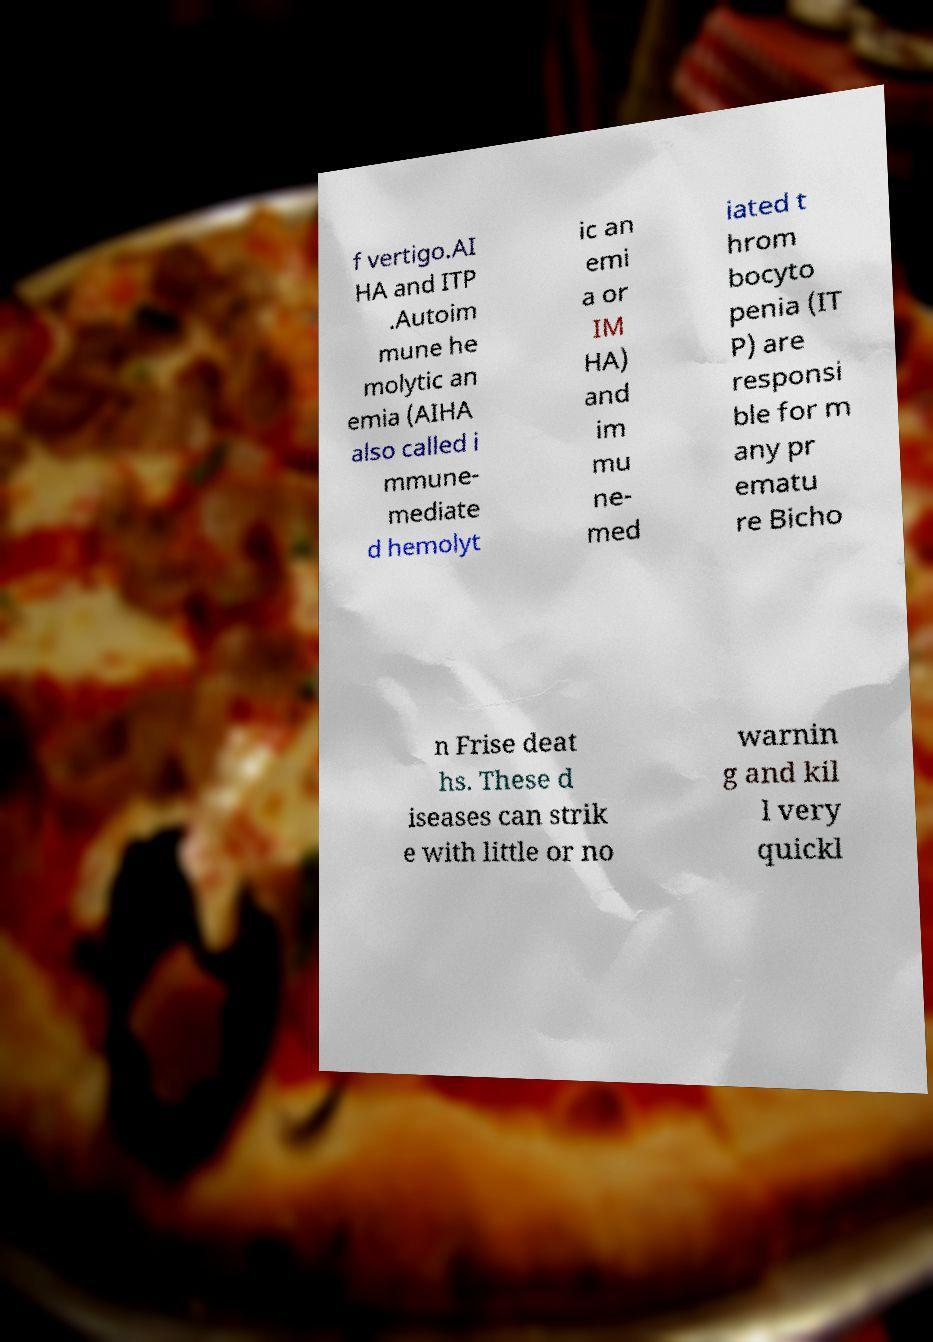What messages or text are displayed in this image? I need them in a readable, typed format. f vertigo.AI HA and ITP .Autoim mune he molytic an emia (AIHA also called i mmune- mediate d hemolyt ic an emi a or IM HA) and im mu ne- med iated t hrom bocyto penia (IT P) are responsi ble for m any pr ematu re Bicho n Frise deat hs. These d iseases can strik e with little or no warnin g and kil l very quickl 